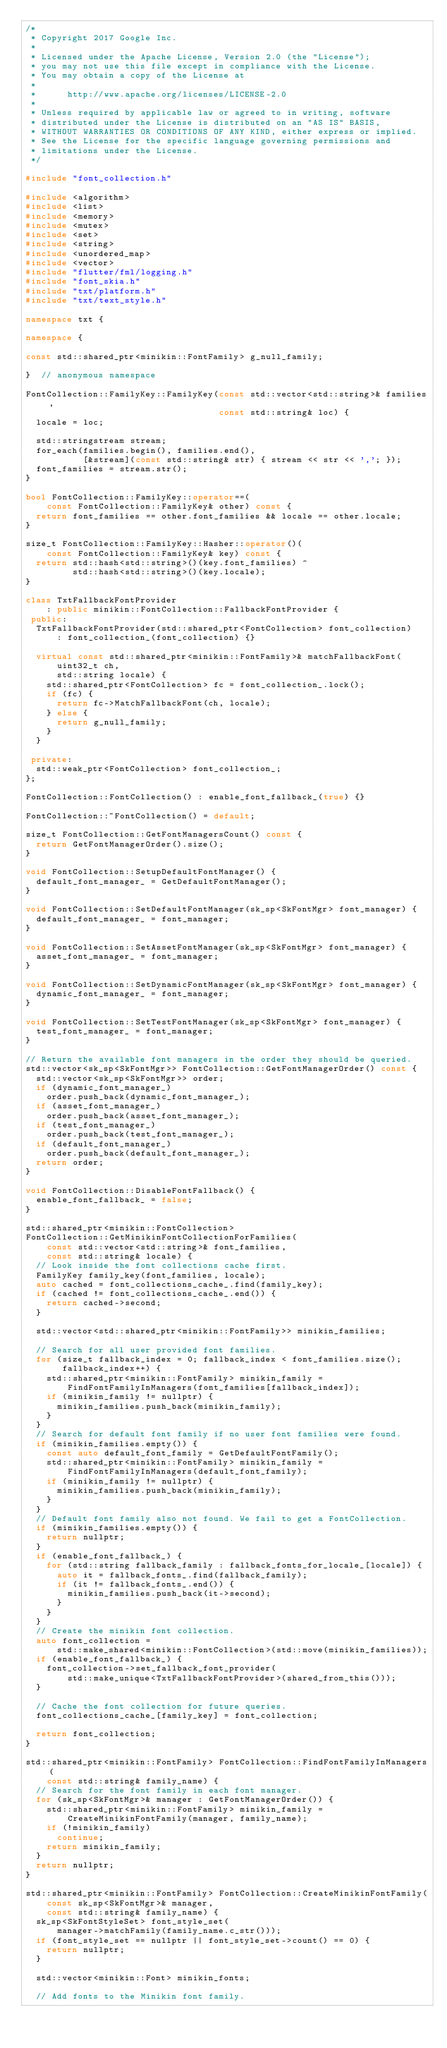Convert code to text. <code><loc_0><loc_0><loc_500><loc_500><_C++_>/*
 * Copyright 2017 Google Inc.
 *
 * Licensed under the Apache License, Version 2.0 (the "License");
 * you may not use this file except in compliance with the License.
 * You may obtain a copy of the License at
 *
 *      http://www.apache.org/licenses/LICENSE-2.0
 *
 * Unless required by applicable law or agreed to in writing, software
 * distributed under the License is distributed on an "AS IS" BASIS,
 * WITHOUT WARRANTIES OR CONDITIONS OF ANY KIND, either express or implied.
 * See the License for the specific language governing permissions and
 * limitations under the License.
 */

#include "font_collection.h"

#include <algorithm>
#include <list>
#include <memory>
#include <mutex>
#include <set>
#include <string>
#include <unordered_map>
#include <vector>
#include "flutter/fml/logging.h"
#include "font_skia.h"
#include "txt/platform.h"
#include "txt/text_style.h"

namespace txt {

namespace {

const std::shared_ptr<minikin::FontFamily> g_null_family;

}  // anonymous namespace

FontCollection::FamilyKey::FamilyKey(const std::vector<std::string>& families,
                                     const std::string& loc) {
  locale = loc;

  std::stringstream stream;
  for_each(families.begin(), families.end(),
           [&stream](const std::string& str) { stream << str << ','; });
  font_families = stream.str();
}

bool FontCollection::FamilyKey::operator==(
    const FontCollection::FamilyKey& other) const {
  return font_families == other.font_families && locale == other.locale;
}

size_t FontCollection::FamilyKey::Hasher::operator()(
    const FontCollection::FamilyKey& key) const {
  return std::hash<std::string>()(key.font_families) ^
         std::hash<std::string>()(key.locale);
}

class TxtFallbackFontProvider
    : public minikin::FontCollection::FallbackFontProvider {
 public:
  TxtFallbackFontProvider(std::shared_ptr<FontCollection> font_collection)
      : font_collection_(font_collection) {}

  virtual const std::shared_ptr<minikin::FontFamily>& matchFallbackFont(
      uint32_t ch,
      std::string locale) {
    std::shared_ptr<FontCollection> fc = font_collection_.lock();
    if (fc) {
      return fc->MatchFallbackFont(ch, locale);
    } else {
      return g_null_family;
    }
  }

 private:
  std::weak_ptr<FontCollection> font_collection_;
};

FontCollection::FontCollection() : enable_font_fallback_(true) {}

FontCollection::~FontCollection() = default;

size_t FontCollection::GetFontManagersCount() const {
  return GetFontManagerOrder().size();
}

void FontCollection::SetupDefaultFontManager() {
  default_font_manager_ = GetDefaultFontManager();
}

void FontCollection::SetDefaultFontManager(sk_sp<SkFontMgr> font_manager) {
  default_font_manager_ = font_manager;
}

void FontCollection::SetAssetFontManager(sk_sp<SkFontMgr> font_manager) {
  asset_font_manager_ = font_manager;
}

void FontCollection::SetDynamicFontManager(sk_sp<SkFontMgr> font_manager) {
  dynamic_font_manager_ = font_manager;
}

void FontCollection::SetTestFontManager(sk_sp<SkFontMgr> font_manager) {
  test_font_manager_ = font_manager;
}

// Return the available font managers in the order they should be queried.
std::vector<sk_sp<SkFontMgr>> FontCollection::GetFontManagerOrder() const {
  std::vector<sk_sp<SkFontMgr>> order;
  if (dynamic_font_manager_)
    order.push_back(dynamic_font_manager_);
  if (asset_font_manager_)
    order.push_back(asset_font_manager_);
  if (test_font_manager_)
    order.push_back(test_font_manager_);
  if (default_font_manager_)
    order.push_back(default_font_manager_);
  return order;
}

void FontCollection::DisableFontFallback() {
  enable_font_fallback_ = false;
}

std::shared_ptr<minikin::FontCollection>
FontCollection::GetMinikinFontCollectionForFamilies(
    const std::vector<std::string>& font_families,
    const std::string& locale) {
  // Look inside the font collections cache first.
  FamilyKey family_key(font_families, locale);
  auto cached = font_collections_cache_.find(family_key);
  if (cached != font_collections_cache_.end()) {
    return cached->second;
  }

  std::vector<std::shared_ptr<minikin::FontFamily>> minikin_families;

  // Search for all user provided font families.
  for (size_t fallback_index = 0; fallback_index < font_families.size();
       fallback_index++) {
    std::shared_ptr<minikin::FontFamily> minikin_family =
        FindFontFamilyInManagers(font_families[fallback_index]);
    if (minikin_family != nullptr) {
      minikin_families.push_back(minikin_family);
    }
  }
  // Search for default font family if no user font families were found.
  if (minikin_families.empty()) {
    const auto default_font_family = GetDefaultFontFamily();
    std::shared_ptr<minikin::FontFamily> minikin_family =
        FindFontFamilyInManagers(default_font_family);
    if (minikin_family != nullptr) {
      minikin_families.push_back(minikin_family);
    }
  }
  // Default font family also not found. We fail to get a FontCollection.
  if (minikin_families.empty()) {
    return nullptr;
  }
  if (enable_font_fallback_) {
    for (std::string fallback_family : fallback_fonts_for_locale_[locale]) {
      auto it = fallback_fonts_.find(fallback_family);
      if (it != fallback_fonts_.end()) {
        minikin_families.push_back(it->second);
      }
    }
  }
  // Create the minikin font collection.
  auto font_collection =
      std::make_shared<minikin::FontCollection>(std::move(minikin_families));
  if (enable_font_fallback_) {
    font_collection->set_fallback_font_provider(
        std::make_unique<TxtFallbackFontProvider>(shared_from_this()));
  }

  // Cache the font collection for future queries.
  font_collections_cache_[family_key] = font_collection;

  return font_collection;
}

std::shared_ptr<minikin::FontFamily> FontCollection::FindFontFamilyInManagers(
    const std::string& family_name) {
  // Search for the font family in each font manager.
  for (sk_sp<SkFontMgr>& manager : GetFontManagerOrder()) {
    std::shared_ptr<minikin::FontFamily> minikin_family =
        CreateMinikinFontFamily(manager, family_name);
    if (!minikin_family)
      continue;
    return minikin_family;
  }
  return nullptr;
}

std::shared_ptr<minikin::FontFamily> FontCollection::CreateMinikinFontFamily(
    const sk_sp<SkFontMgr>& manager,
    const std::string& family_name) {
  sk_sp<SkFontStyleSet> font_style_set(
      manager->matchFamily(family_name.c_str()));
  if (font_style_set == nullptr || font_style_set->count() == 0) {
    return nullptr;
  }

  std::vector<minikin::Font> minikin_fonts;

  // Add fonts to the Minikin font family.</code> 